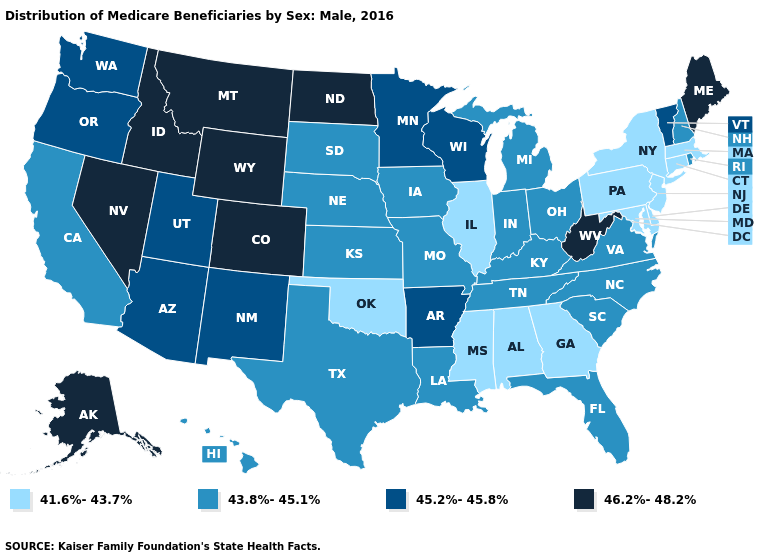What is the value of Colorado?
Answer briefly. 46.2%-48.2%. Name the states that have a value in the range 43.8%-45.1%?
Short answer required. California, Florida, Hawaii, Indiana, Iowa, Kansas, Kentucky, Louisiana, Michigan, Missouri, Nebraska, New Hampshire, North Carolina, Ohio, Rhode Island, South Carolina, South Dakota, Tennessee, Texas, Virginia. What is the value of Pennsylvania?
Short answer required. 41.6%-43.7%. Name the states that have a value in the range 45.2%-45.8%?
Concise answer only. Arizona, Arkansas, Minnesota, New Mexico, Oregon, Utah, Vermont, Washington, Wisconsin. Which states have the lowest value in the USA?
Short answer required. Alabama, Connecticut, Delaware, Georgia, Illinois, Maryland, Massachusetts, Mississippi, New Jersey, New York, Oklahoma, Pennsylvania. What is the highest value in the USA?
Answer briefly. 46.2%-48.2%. Name the states that have a value in the range 41.6%-43.7%?
Answer briefly. Alabama, Connecticut, Delaware, Georgia, Illinois, Maryland, Massachusetts, Mississippi, New Jersey, New York, Oklahoma, Pennsylvania. What is the value of Vermont?
Be succinct. 45.2%-45.8%. What is the lowest value in the USA?
Give a very brief answer. 41.6%-43.7%. Does the first symbol in the legend represent the smallest category?
Write a very short answer. Yes. Does North Dakota have a lower value than South Carolina?
Quick response, please. No. Among the states that border New Hampshire , does Massachusetts have the lowest value?
Answer briefly. Yes. What is the value of California?
Concise answer only. 43.8%-45.1%. Does Massachusetts have the highest value in the Northeast?
Give a very brief answer. No. Does the first symbol in the legend represent the smallest category?
Answer briefly. Yes. 